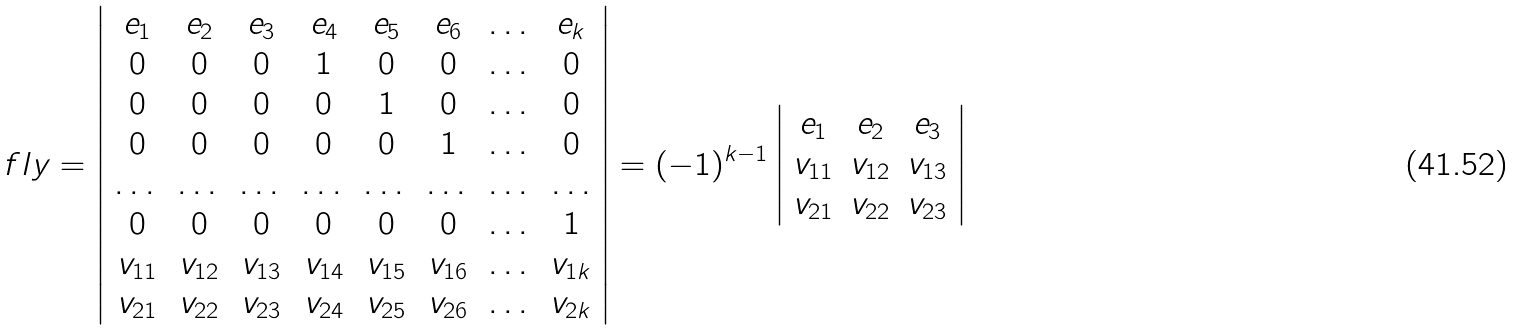Convert formula to latex. <formula><loc_0><loc_0><loc_500><loc_500>\ f l y = \left | \begin{array} { c c c c c c c c } e _ { 1 } & e _ { 2 } & e _ { 3 } & e _ { 4 } & e _ { 5 } & e _ { 6 } & \dots & e _ { k } \\ 0 & 0 & 0 & 1 & 0 & 0 & \dots & 0 \\ 0 & 0 & 0 & 0 & 1 & 0 & \dots & 0 \\ 0 & 0 & 0 & 0 & 0 & 1 & \dots & 0 \\ \dots & \dots & \dots & \dots & \dots & \dots & \dots & \dots \\ 0 & 0 & 0 & 0 & 0 & 0 & \dots & 1 \\ v _ { 1 1 } & v _ { 1 2 } & v _ { 1 3 } & v _ { 1 4 } & v _ { 1 5 } & v _ { 1 6 } & \dots & v _ { 1 k } \\ v _ { 2 1 } & v _ { 2 2 } & v _ { 2 3 } & v _ { 2 4 } & v _ { 2 5 } & v _ { 2 6 } & \dots & v _ { 2 k } \\ \end{array} \right | = ( - 1 ) ^ { k - 1 } \left | \begin{array} { c c c } e _ { 1 } & e _ { 2 } & e _ { 3 } \\ v _ { 1 1 } & v _ { 1 2 } & v _ { 1 3 } \\ v _ { 2 1 } & v _ { 2 2 } & v _ { 2 3 } \end{array} \right |</formula> 